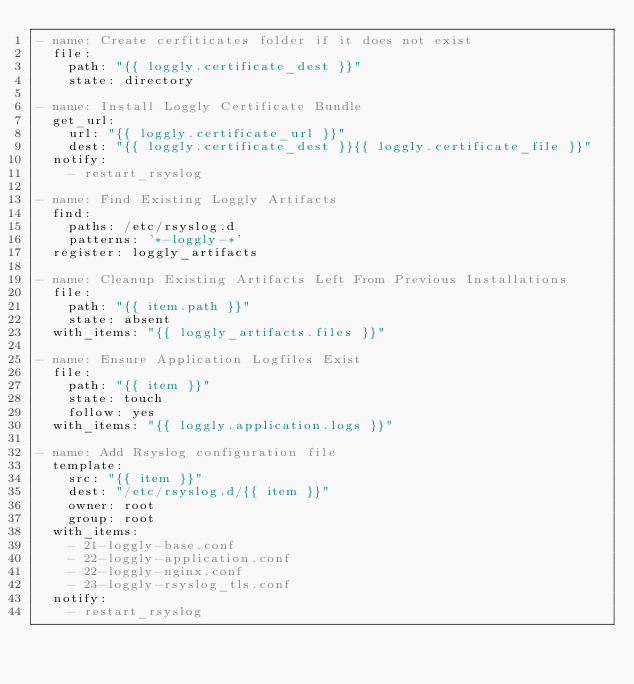<code> <loc_0><loc_0><loc_500><loc_500><_YAML_>- name: Create cerfiticates folder if it does not exist
  file:
    path: "{{ loggly.certificate_dest }}"
    state: directory

- name: Install Loggly Certificate Bundle
  get_url:
    url: "{{ loggly.certificate_url }}"
    dest: "{{ loggly.certificate_dest }}{{ loggly.certificate_file }}"
  notify:
    - restart_rsyslog

- name: Find Existing Loggly Artifacts
  find:
    paths: /etc/rsyslog.d
    patterns: '*-loggly-*'
  register: loggly_artifacts

- name: Cleanup Existing Artifacts Left From Previous Installations
  file:
    path: "{{ item.path }}"
    state: absent
  with_items: "{{ loggly_artifacts.files }}"

- name: Ensure Application Logfiles Exist
  file:
    path: "{{ item }}"
    state: touch
    follow: yes
  with_items: "{{ loggly.application.logs }}"

- name: Add Rsyslog configuration file
  template:
    src: "{{ item }}"
    dest: "/etc/rsyslog.d/{{ item }}"
    owner: root
    group: root
  with_items:
    - 21-loggly-base.conf
    - 22-loggly-application.conf
    - 22-loggly-nginx.conf
    - 23-loggly-rsyslog_tls.conf
  notify:
    - restart_rsyslog
</code> 